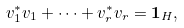<formula> <loc_0><loc_0><loc_500><loc_500>v _ { 1 } ^ { * } v _ { 1 } + \cdots + v _ { r } ^ { * } v _ { r } = \mathbf 1 _ { H } ,</formula> 